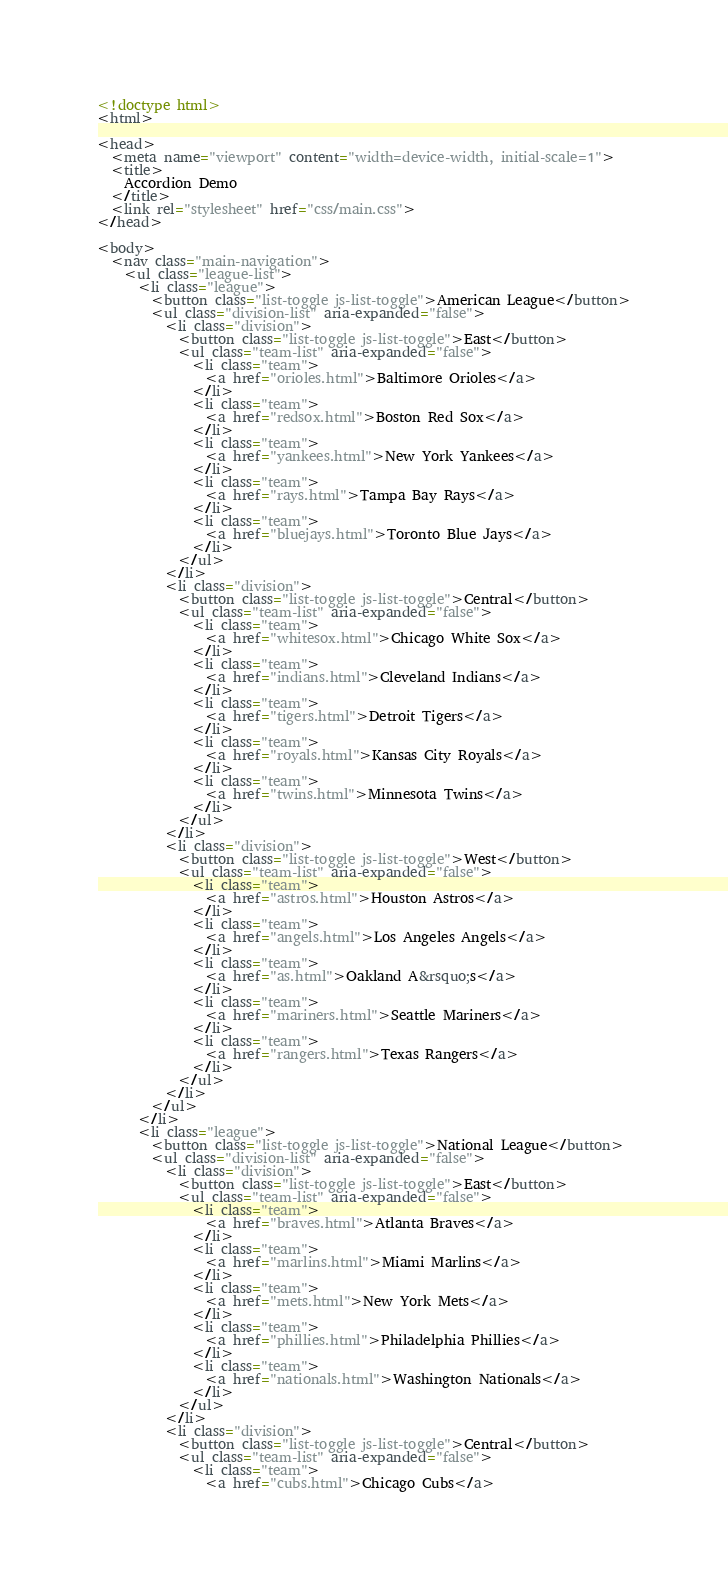Convert code to text. <code><loc_0><loc_0><loc_500><loc_500><_HTML_><!doctype html>
<html>

<head>
  <meta name="viewport" content="width=device-width, initial-scale=1">
  <title>
    Accordion Demo
  </title>
  <link rel="stylesheet" href="css/main.css">
</head>

<body>
  <nav class="main-navigation">
    <ul class="league-list">
      <li class="league">
        <button class="list-toggle js-list-toggle">American League</button>
        <ul class="division-list" aria-expanded="false">
          <li class="division">
            <button class="list-toggle js-list-toggle">East</button>
            <ul class="team-list" aria-expanded="false">
              <li class="team">
                <a href="orioles.html">Baltimore Orioles</a>
              </li>
              <li class="team">
                <a href="redsox.html">Boston Red Sox</a>
              </li>
              <li class="team">
                <a href="yankees.html">New York Yankees</a>
              </li>
              <li class="team">
                <a href="rays.html">Tampa Bay Rays</a>
              </li>
              <li class="team">
                <a href="bluejays.html">Toronto Blue Jays</a>
              </li>
            </ul>
          </li>
          <li class="division">
            <button class="list-toggle js-list-toggle">Central</button>
            <ul class="team-list" aria-expanded="false">
              <li class="team">
                <a href="whitesox.html">Chicago White Sox</a>
              </li>
              <li class="team">
                <a href="indians.html">Cleveland Indians</a>
              </li>
              <li class="team">
                <a href="tigers.html">Detroit Tigers</a>
              </li>
              <li class="team">
                <a href="royals.html">Kansas City Royals</a>
              </li>
              <li class="team">
                <a href="twins.html">Minnesota Twins</a>
              </li>
            </ul>
          </li>
          <li class="division">
            <button class="list-toggle js-list-toggle">West</button>
            <ul class="team-list" aria-expanded="false">
              <li class="team">
                <a href="astros.html">Houston Astros</a>
              </li>
              <li class="team">
                <a href="angels.html">Los Angeles Angels</a>
              </li>
              <li class="team">
                <a href="as.html">Oakland A&rsquo;s</a>
              </li>
              <li class="team">
                <a href="mariners.html">Seattle Mariners</a>
              </li>
              <li class="team">
                <a href="rangers.html">Texas Rangers</a>
              </li>
            </ul>
          </li>
        </ul>
      </li>
      <li class="league">
        <button class="list-toggle js-list-toggle">National League</button>
        <ul class="division-list" aria-expanded="false">
          <li class="division">
            <button class="list-toggle js-list-toggle">East</button>
            <ul class="team-list" aria-expanded="false">
              <li class="team">
                <a href="braves.html">Atlanta Braves</a>
              </li>
              <li class="team">
                <a href="marlins.html">Miami Marlins</a>
              </li>
              <li class="team">
                <a href="mets.html">New York Mets</a>
              </li>
              <li class="team">
                <a href="phillies.html">Philadelphia Phillies</a>
              </li>
              <li class="team">
                <a href="nationals.html">Washington Nationals</a>
              </li>
            </ul>
          </li>
          <li class="division">
            <button class="list-toggle js-list-toggle">Central</button>
            <ul class="team-list" aria-expanded="false">
              <li class="team">
                <a href="cubs.html">Chicago Cubs</a></code> 